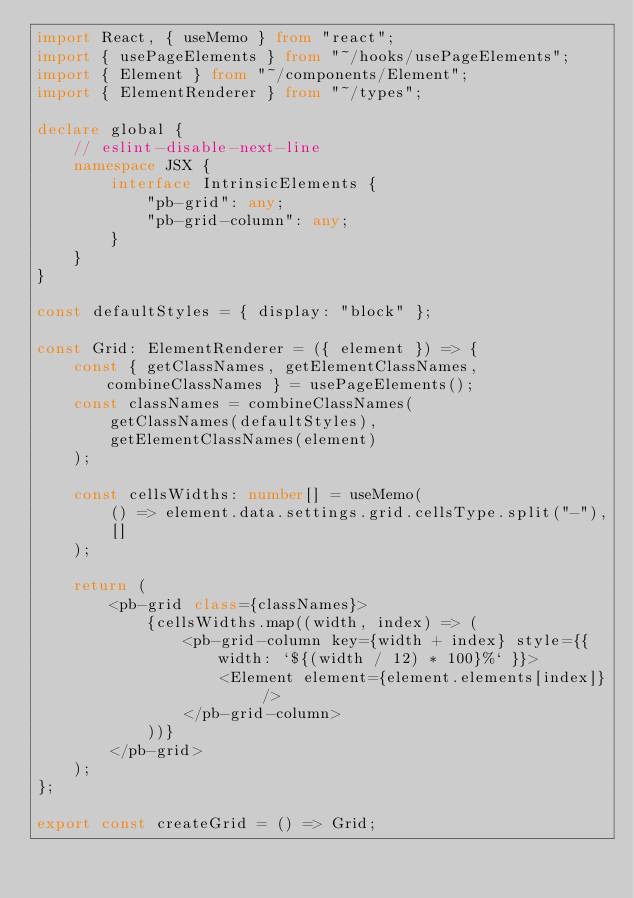<code> <loc_0><loc_0><loc_500><loc_500><_TypeScript_>import React, { useMemo } from "react";
import { usePageElements } from "~/hooks/usePageElements";
import { Element } from "~/components/Element";
import { ElementRenderer } from "~/types";

declare global {
    // eslint-disable-next-line
    namespace JSX {
        interface IntrinsicElements {
            "pb-grid": any;
            "pb-grid-column": any;
        }
    }
}

const defaultStyles = { display: "block" };

const Grid: ElementRenderer = ({ element }) => {
    const { getClassNames, getElementClassNames, combineClassNames } = usePageElements();
    const classNames = combineClassNames(
        getClassNames(defaultStyles),
        getElementClassNames(element)
    );

    const cellsWidths: number[] = useMemo(
        () => element.data.settings.grid.cellsType.split("-"),
        []
    );

    return (
        <pb-grid class={classNames}>
            {cellsWidths.map((width, index) => (
                <pb-grid-column key={width + index} style={{ width: `${(width / 12) * 100}%` }}>
                    <Element element={element.elements[index]} />
                </pb-grid-column>
            ))}
        </pb-grid>
    );
};

export const createGrid = () => Grid;
</code> 